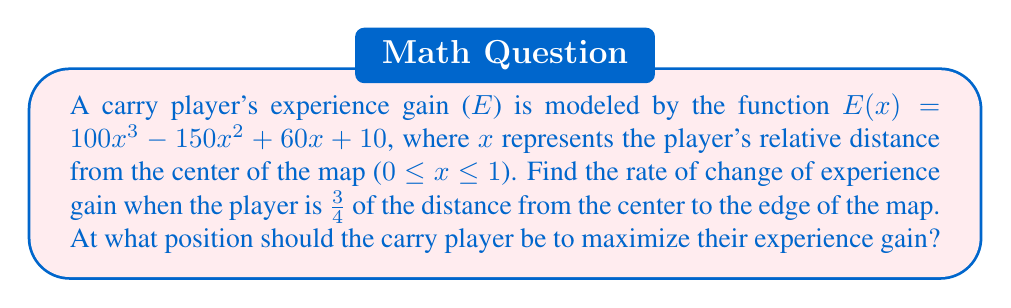Help me with this question. To solve this problem, we need to follow these steps:

1. Find the derivative of the experience gain function:
   $$E'(x) = \frac{d}{dx}(100x^3 - 150x^2 + 60x + 10)$$
   $$E'(x) = 300x^2 - 300x + 60$$

2. Calculate the rate of change at x = 3/4:
   $$E'(3/4) = 300(3/4)^2 - 300(3/4) + 60$$
   $$E'(3/4) = 300(9/16) - 300(3/4) + 60$$
   $$E'(3/4) = 168.75 - 225 + 60$$
   $$E'(3/4) = 3.75$$

3. To find the position that maximizes experience gain, we need to find the critical points:
   Set $E'(x) = 0$ and solve for x:
   $$300x^2 - 300x + 60 = 0$$
   $$x^2 - x + 1/5 = 0$$
   
   Using the quadratic formula:
   $$x = \frac{1 \pm \sqrt{1 - 4(1)(1/5)}}{2(1)}$$
   $$x = \frac{1 \pm \sqrt{0.2}}{2}$$

   $$x_1 = \frac{1 + \sqrt{0.2}}{2} \approx 0.7236$$
   $$x_2 = \frac{1 - \sqrt{0.2}}{2} \approx 0.2764$$

4. To determine which critical point is the maximum, we can use the second derivative test:
   $$E''(x) = 600x - 300$$
   
   At $x_1 \approx 0.7236$:
   $$E''(0.7236) \approx 134.16 > 0$$ (local minimum)
   
   At $x_2 \approx 0.2764$:
   $$E''(0.2764) \approx -134.16 < 0$$ (local maximum)

Therefore, the experience gain is maximized at $x \approx 0.2764$, or about 27.64% of the distance from the center to the edge of the map.
Answer: Rate of change at x = 3/4: 3.75; Optimal position: x ≈ 0.2764 